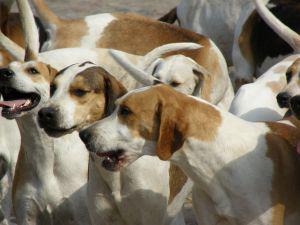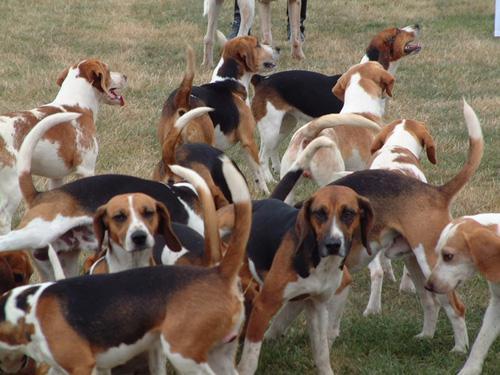The first image is the image on the left, the second image is the image on the right. Assess this claim about the two images: "A man in a cap and blazer stands holding a whip-shaped item, with a pack of beagles around him.". Correct or not? Answer yes or no. No. The first image is the image on the left, the second image is the image on the right. For the images shown, is this caption "A man is standing with the dogs in the image on the left." true? Answer yes or no. No. 